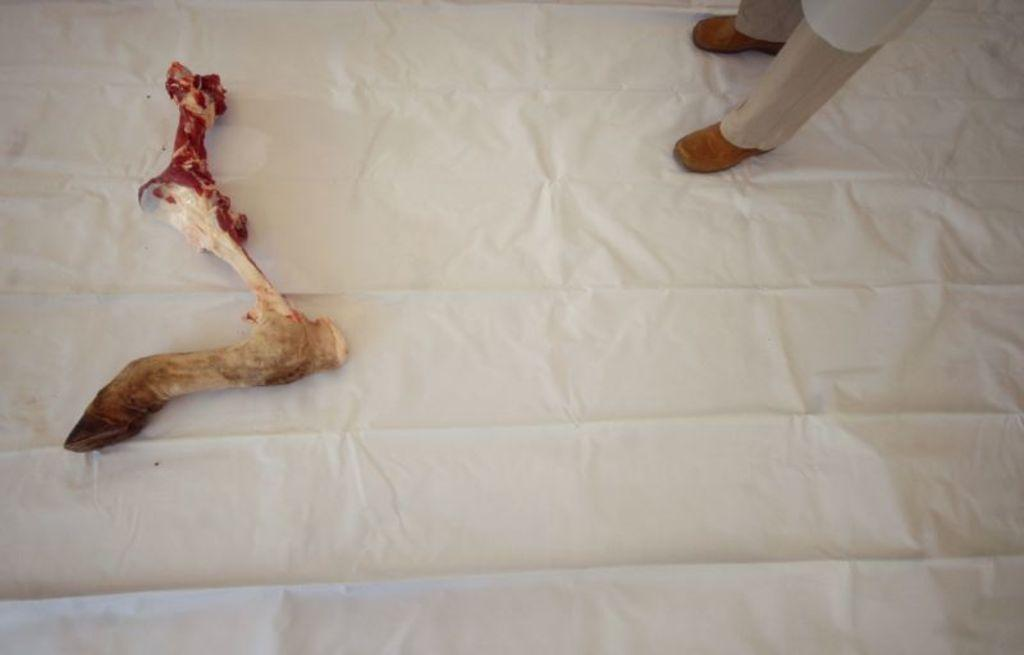What can be seen at the bottom of the image? There are legs with shoes visible shoes visible in the image. What object is present in the image that is commonly associated with dogs? There is a bone present in the image. What type of material can be seen in the image? There is a white color cloth in the image. What type of riddle is being solved by the eggnog in the image? There is no eggnog present in the image, and therefore no riddle-solving can be observed. What type of produce is being harvested in the image? There is no produce present in the image, and therefore no harvesting can be observed. 